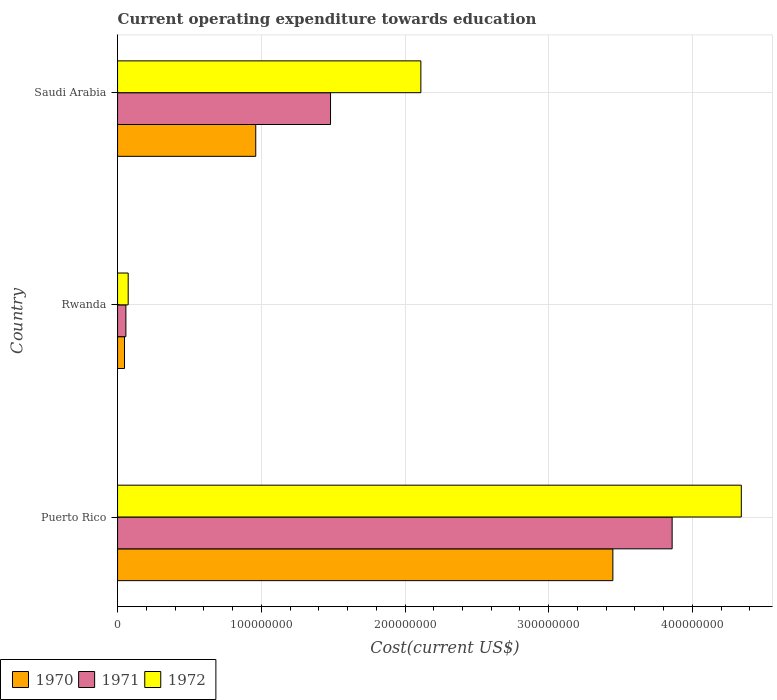How many groups of bars are there?
Your response must be concise. 3. Are the number of bars on each tick of the Y-axis equal?
Provide a succinct answer. Yes. What is the label of the 1st group of bars from the top?
Provide a short and direct response. Saudi Arabia. In how many cases, is the number of bars for a given country not equal to the number of legend labels?
Keep it short and to the point. 0. What is the expenditure towards education in 1971 in Rwanda?
Keep it short and to the point. 5.80e+06. Across all countries, what is the maximum expenditure towards education in 1970?
Give a very brief answer. 3.45e+08. Across all countries, what is the minimum expenditure towards education in 1970?
Make the answer very short. 4.84e+06. In which country was the expenditure towards education in 1971 maximum?
Your response must be concise. Puerto Rico. In which country was the expenditure towards education in 1972 minimum?
Your response must be concise. Rwanda. What is the total expenditure towards education in 1972 in the graph?
Provide a succinct answer. 6.52e+08. What is the difference between the expenditure towards education in 1970 in Puerto Rico and that in Saudi Arabia?
Provide a succinct answer. 2.48e+08. What is the difference between the expenditure towards education in 1972 in Rwanda and the expenditure towards education in 1971 in Puerto Rico?
Provide a succinct answer. -3.78e+08. What is the average expenditure towards education in 1972 per country?
Provide a short and direct response. 2.17e+08. What is the difference between the expenditure towards education in 1970 and expenditure towards education in 1972 in Puerto Rico?
Make the answer very short. -8.94e+07. What is the ratio of the expenditure towards education in 1970 in Puerto Rico to that in Rwanda?
Your response must be concise. 71.2. What is the difference between the highest and the second highest expenditure towards education in 1971?
Provide a succinct answer. 2.38e+08. What is the difference between the highest and the lowest expenditure towards education in 1971?
Offer a very short reply. 3.80e+08. Is the sum of the expenditure towards education in 1970 in Rwanda and Saudi Arabia greater than the maximum expenditure towards education in 1972 across all countries?
Provide a short and direct response. No. What does the 1st bar from the bottom in Rwanda represents?
Offer a terse response. 1970. How many countries are there in the graph?
Offer a very short reply. 3. Are the values on the major ticks of X-axis written in scientific E-notation?
Your answer should be compact. No. Does the graph contain any zero values?
Keep it short and to the point. No. Does the graph contain grids?
Provide a short and direct response. Yes. How are the legend labels stacked?
Offer a very short reply. Horizontal. What is the title of the graph?
Provide a short and direct response. Current operating expenditure towards education. What is the label or title of the X-axis?
Offer a terse response. Cost(current US$). What is the label or title of the Y-axis?
Offer a terse response. Country. What is the Cost(current US$) in 1970 in Puerto Rico?
Make the answer very short. 3.45e+08. What is the Cost(current US$) in 1971 in Puerto Rico?
Give a very brief answer. 3.86e+08. What is the Cost(current US$) in 1972 in Puerto Rico?
Ensure brevity in your answer.  4.34e+08. What is the Cost(current US$) of 1970 in Rwanda?
Keep it short and to the point. 4.84e+06. What is the Cost(current US$) in 1971 in Rwanda?
Keep it short and to the point. 5.80e+06. What is the Cost(current US$) in 1972 in Rwanda?
Keep it short and to the point. 7.40e+06. What is the Cost(current US$) of 1970 in Saudi Arabia?
Your response must be concise. 9.62e+07. What is the Cost(current US$) of 1971 in Saudi Arabia?
Provide a short and direct response. 1.48e+08. What is the Cost(current US$) in 1972 in Saudi Arabia?
Offer a terse response. 2.11e+08. Across all countries, what is the maximum Cost(current US$) of 1970?
Your answer should be compact. 3.45e+08. Across all countries, what is the maximum Cost(current US$) of 1971?
Offer a terse response. 3.86e+08. Across all countries, what is the maximum Cost(current US$) of 1972?
Offer a very short reply. 4.34e+08. Across all countries, what is the minimum Cost(current US$) in 1970?
Keep it short and to the point. 4.84e+06. Across all countries, what is the minimum Cost(current US$) of 1971?
Make the answer very short. 5.80e+06. Across all countries, what is the minimum Cost(current US$) in 1972?
Provide a succinct answer. 7.40e+06. What is the total Cost(current US$) of 1970 in the graph?
Offer a terse response. 4.46e+08. What is the total Cost(current US$) in 1971 in the graph?
Give a very brief answer. 5.40e+08. What is the total Cost(current US$) in 1972 in the graph?
Offer a terse response. 6.52e+08. What is the difference between the Cost(current US$) in 1970 in Puerto Rico and that in Rwanda?
Provide a short and direct response. 3.40e+08. What is the difference between the Cost(current US$) in 1971 in Puerto Rico and that in Rwanda?
Give a very brief answer. 3.80e+08. What is the difference between the Cost(current US$) in 1972 in Puerto Rico and that in Rwanda?
Your answer should be very brief. 4.27e+08. What is the difference between the Cost(current US$) in 1970 in Puerto Rico and that in Saudi Arabia?
Make the answer very short. 2.48e+08. What is the difference between the Cost(current US$) of 1971 in Puerto Rico and that in Saudi Arabia?
Give a very brief answer. 2.38e+08. What is the difference between the Cost(current US$) in 1972 in Puerto Rico and that in Saudi Arabia?
Keep it short and to the point. 2.23e+08. What is the difference between the Cost(current US$) in 1970 in Rwanda and that in Saudi Arabia?
Your response must be concise. -9.13e+07. What is the difference between the Cost(current US$) in 1971 in Rwanda and that in Saudi Arabia?
Give a very brief answer. -1.42e+08. What is the difference between the Cost(current US$) of 1972 in Rwanda and that in Saudi Arabia?
Provide a succinct answer. -2.04e+08. What is the difference between the Cost(current US$) in 1970 in Puerto Rico and the Cost(current US$) in 1971 in Rwanda?
Your response must be concise. 3.39e+08. What is the difference between the Cost(current US$) of 1970 in Puerto Rico and the Cost(current US$) of 1972 in Rwanda?
Provide a succinct answer. 3.37e+08. What is the difference between the Cost(current US$) in 1971 in Puerto Rico and the Cost(current US$) in 1972 in Rwanda?
Your response must be concise. 3.78e+08. What is the difference between the Cost(current US$) of 1970 in Puerto Rico and the Cost(current US$) of 1971 in Saudi Arabia?
Provide a short and direct response. 1.96e+08. What is the difference between the Cost(current US$) of 1970 in Puerto Rico and the Cost(current US$) of 1972 in Saudi Arabia?
Provide a succinct answer. 1.34e+08. What is the difference between the Cost(current US$) in 1971 in Puerto Rico and the Cost(current US$) in 1972 in Saudi Arabia?
Ensure brevity in your answer.  1.75e+08. What is the difference between the Cost(current US$) of 1970 in Rwanda and the Cost(current US$) of 1971 in Saudi Arabia?
Your answer should be very brief. -1.43e+08. What is the difference between the Cost(current US$) in 1970 in Rwanda and the Cost(current US$) in 1972 in Saudi Arabia?
Your answer should be compact. -2.06e+08. What is the difference between the Cost(current US$) of 1971 in Rwanda and the Cost(current US$) of 1972 in Saudi Arabia?
Your answer should be compact. -2.05e+08. What is the average Cost(current US$) in 1970 per country?
Offer a terse response. 1.49e+08. What is the average Cost(current US$) in 1971 per country?
Keep it short and to the point. 1.80e+08. What is the average Cost(current US$) in 1972 per country?
Your response must be concise. 2.17e+08. What is the difference between the Cost(current US$) in 1970 and Cost(current US$) in 1971 in Puerto Rico?
Give a very brief answer. -4.12e+07. What is the difference between the Cost(current US$) in 1970 and Cost(current US$) in 1972 in Puerto Rico?
Provide a short and direct response. -8.94e+07. What is the difference between the Cost(current US$) of 1971 and Cost(current US$) of 1972 in Puerto Rico?
Provide a succinct answer. -4.81e+07. What is the difference between the Cost(current US$) of 1970 and Cost(current US$) of 1971 in Rwanda?
Ensure brevity in your answer.  -9.57e+05. What is the difference between the Cost(current US$) in 1970 and Cost(current US$) in 1972 in Rwanda?
Ensure brevity in your answer.  -2.56e+06. What is the difference between the Cost(current US$) in 1971 and Cost(current US$) in 1972 in Rwanda?
Offer a very short reply. -1.60e+06. What is the difference between the Cost(current US$) in 1970 and Cost(current US$) in 1971 in Saudi Arabia?
Your response must be concise. -5.20e+07. What is the difference between the Cost(current US$) of 1970 and Cost(current US$) of 1972 in Saudi Arabia?
Offer a terse response. -1.15e+08. What is the difference between the Cost(current US$) in 1971 and Cost(current US$) in 1972 in Saudi Arabia?
Your response must be concise. -6.28e+07. What is the ratio of the Cost(current US$) of 1970 in Puerto Rico to that in Rwanda?
Your answer should be compact. 71.2. What is the ratio of the Cost(current US$) of 1971 in Puerto Rico to that in Rwanda?
Your answer should be very brief. 66.57. What is the ratio of the Cost(current US$) in 1972 in Puerto Rico to that in Rwanda?
Your answer should be compact. 58.67. What is the ratio of the Cost(current US$) of 1970 in Puerto Rico to that in Saudi Arabia?
Your response must be concise. 3.58. What is the ratio of the Cost(current US$) of 1971 in Puerto Rico to that in Saudi Arabia?
Give a very brief answer. 2.6. What is the ratio of the Cost(current US$) in 1972 in Puerto Rico to that in Saudi Arabia?
Give a very brief answer. 2.06. What is the ratio of the Cost(current US$) of 1970 in Rwanda to that in Saudi Arabia?
Offer a terse response. 0.05. What is the ratio of the Cost(current US$) in 1971 in Rwanda to that in Saudi Arabia?
Give a very brief answer. 0.04. What is the ratio of the Cost(current US$) in 1972 in Rwanda to that in Saudi Arabia?
Make the answer very short. 0.04. What is the difference between the highest and the second highest Cost(current US$) in 1970?
Keep it short and to the point. 2.48e+08. What is the difference between the highest and the second highest Cost(current US$) in 1971?
Your answer should be very brief. 2.38e+08. What is the difference between the highest and the second highest Cost(current US$) of 1972?
Make the answer very short. 2.23e+08. What is the difference between the highest and the lowest Cost(current US$) of 1970?
Offer a terse response. 3.40e+08. What is the difference between the highest and the lowest Cost(current US$) in 1971?
Ensure brevity in your answer.  3.80e+08. What is the difference between the highest and the lowest Cost(current US$) of 1972?
Provide a short and direct response. 4.27e+08. 